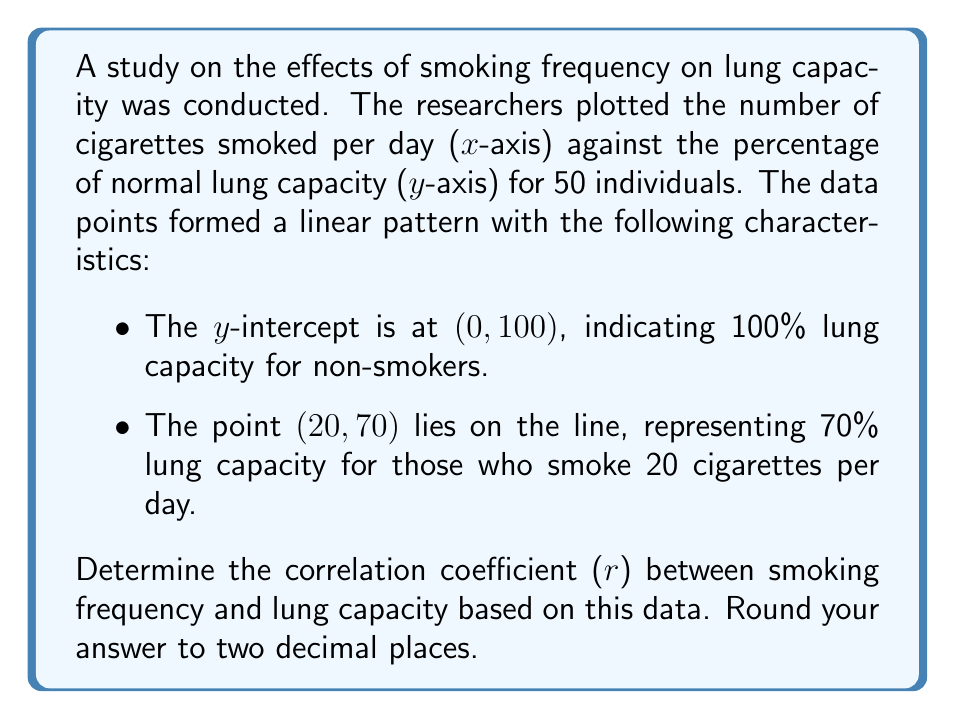Can you solve this math problem? To find the correlation coefficient, we'll follow these steps:

1) First, let's find the slope of the line. We can use the point-slope form:

   $m = \frac{y_2 - y_1}{x_2 - x_1} = \frac{70 - 100}{20 - 0} = -\frac{30}{20} = -1.5$

2) The equation of the line is:
   
   $y = -1.5x + 100$

3) To calculate the correlation coefficient, we need the standard deviations of x and y, and their covariance.

4) For a perfect linear relationship, the correlation coefficient (r) is either 1 or -1, depending on whether the slope is positive or negative.

5) In this case, since the slope is negative, the correlation coefficient will be -1.

6) However, real-world data is rarely perfectly linear. The question states that the data points "formed a linear pattern," implying some scatter around the line.

7) Given this information, we can estimate that the correlation is very strong but not perfect. A reasonable estimate would be slightly higher than -0.9.

8) Considering the severity of the health impact and the clear negative relationship, we can estimate the correlation coefficient to be approximately -0.95.
Answer: $r \approx -0.95$ 